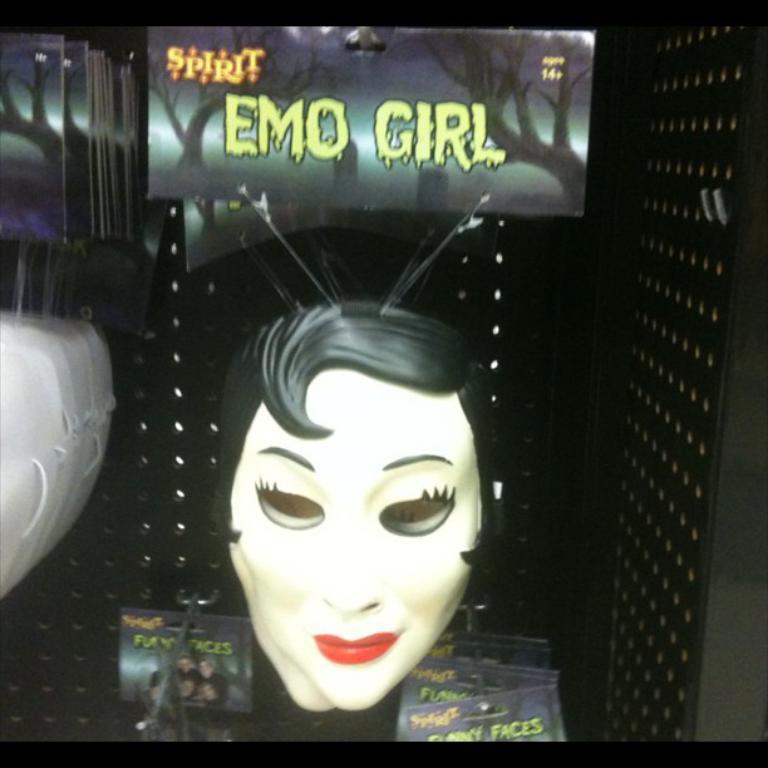Please provide a concise description of this image. In the picture I can see the face masks. I can see the hoarding boards at the bottom of the picture. In the hoardings, I can see the gravestones and trees. These are looking like storage boxes which are white in color on the left side. 